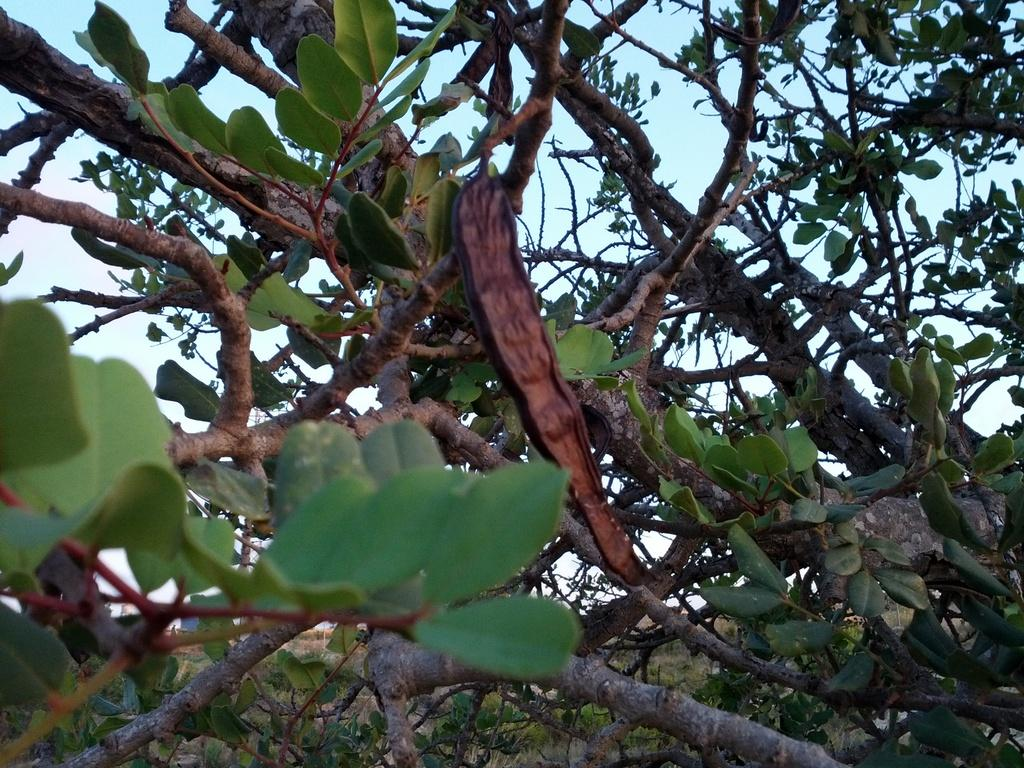What type of vegetation can be seen in the image? There are trees in the image. What part of the natural environment is visible in the image? The sky is visible in the background of the image. How many frogs are sitting on the branches of the trees in the image? There are no frogs present in the image; it only features trees and the sky. 